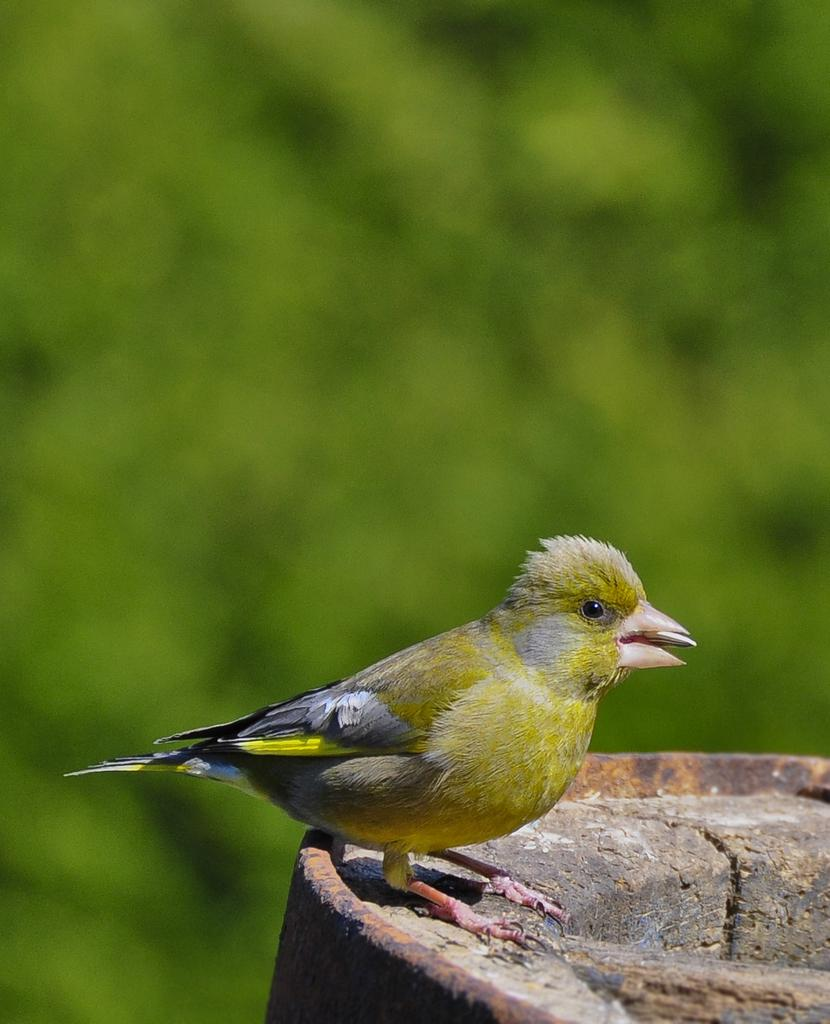What type of animal is in the image? There is a bird in the image. What is the bird standing on? The bird is standing on a stone surface. What color is the background of the image? The background of the image is blue. What type of basket is the bird carrying in the image? There is no basket present in the image; the bird is simply standing on a stone surface. 